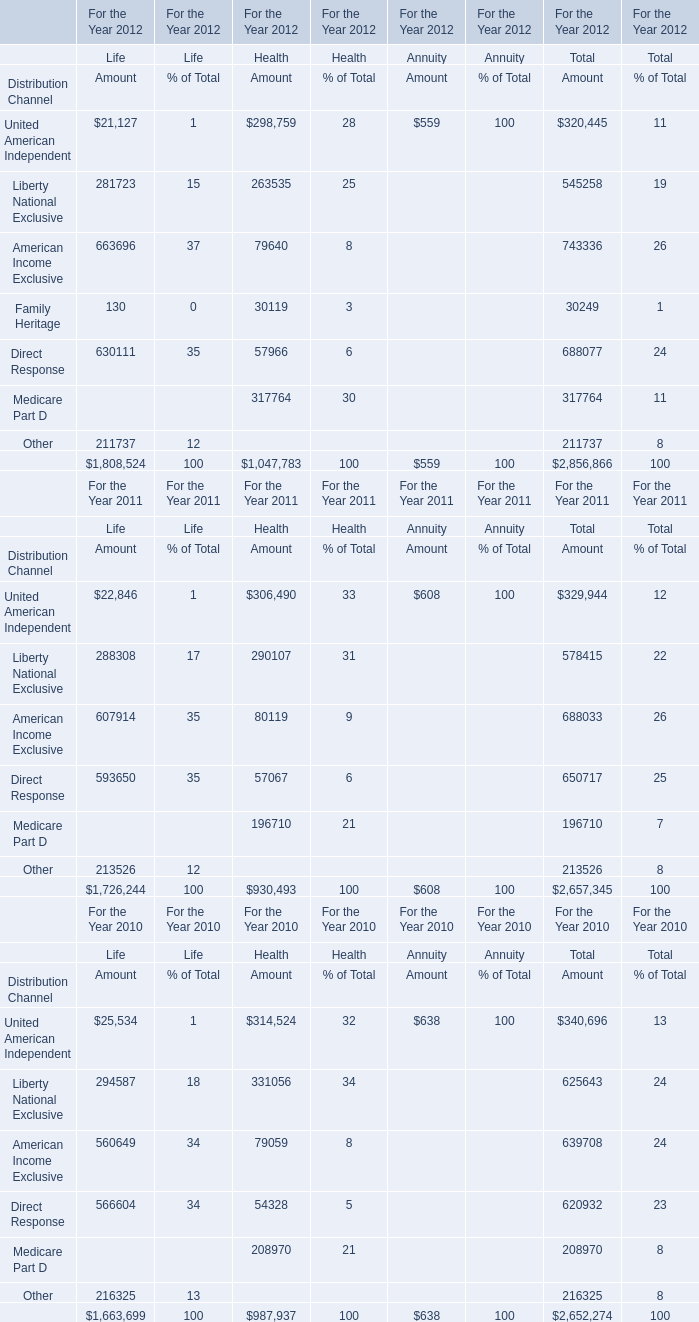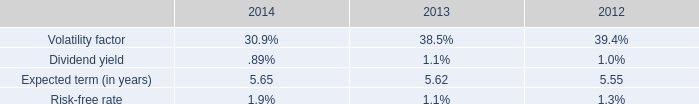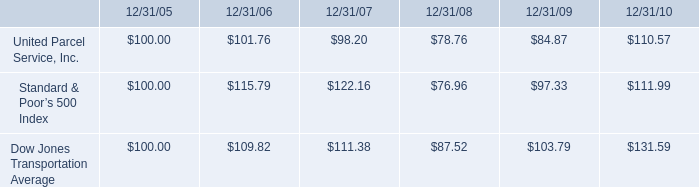What is the ratio of Liberty National Exclusive for Life to the total in 2011? 
Computations: (288308 / 1726244)
Answer: 0.16701. 